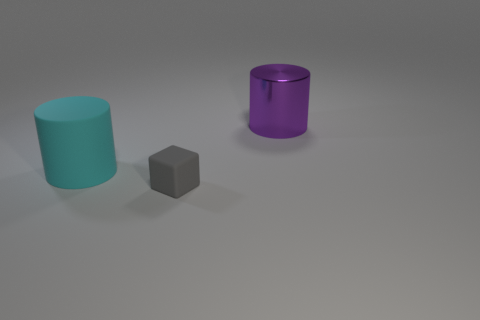Add 2 large objects. How many objects exist? 5 Subtract all blocks. How many objects are left? 2 Subtract all matte cylinders. Subtract all large purple shiny cylinders. How many objects are left? 1 Add 2 large metallic objects. How many large metallic objects are left? 3 Add 1 big matte things. How many big matte things exist? 2 Subtract 0 brown blocks. How many objects are left? 3 